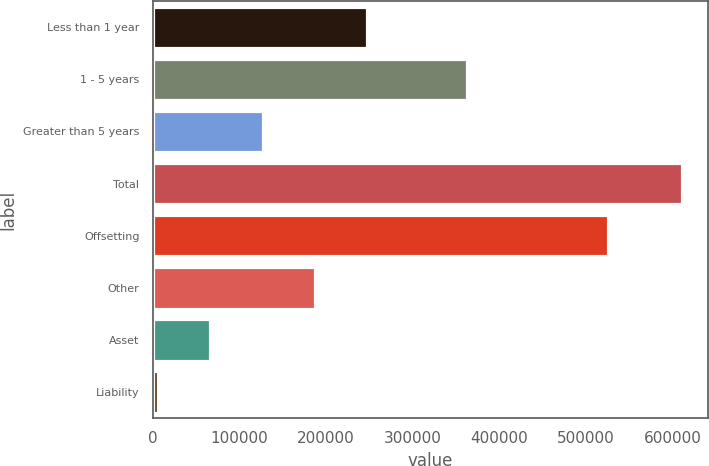Convert chart. <chart><loc_0><loc_0><loc_500><loc_500><bar_chart><fcel>Less than 1 year<fcel>1 - 5 years<fcel>Greater than 5 years<fcel>Total<fcel>Offsetting<fcel>Other<fcel>Asset<fcel>Liability<nl><fcel>247998<fcel>362373<fcel>126984<fcel>611040<fcel>525807<fcel>187491<fcel>66477<fcel>5970<nl></chart> 